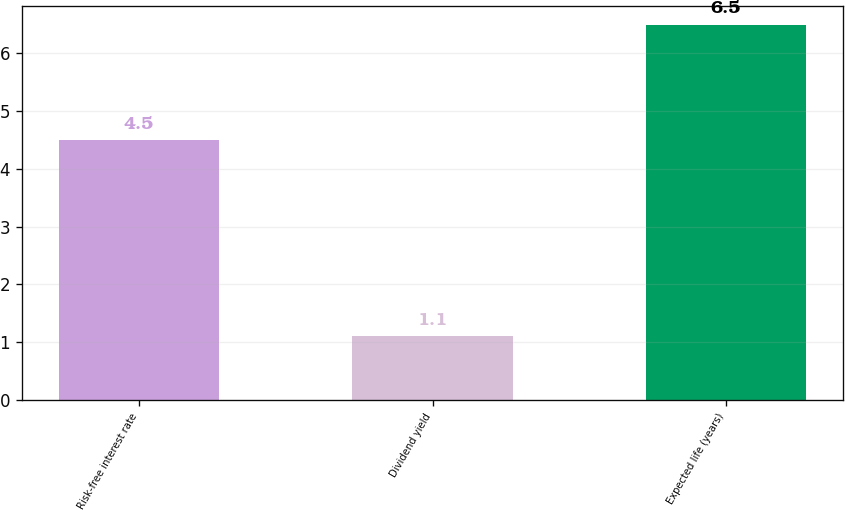Convert chart to OTSL. <chart><loc_0><loc_0><loc_500><loc_500><bar_chart><fcel>Risk-free interest rate<fcel>Dividend yield<fcel>Expected life (years)<nl><fcel>4.5<fcel>1.1<fcel>6.5<nl></chart> 